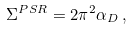Convert formula to latex. <formula><loc_0><loc_0><loc_500><loc_500>\Sigma ^ { P S R } = 2 \pi ^ { 2 } \alpha _ { D } \, ,</formula> 